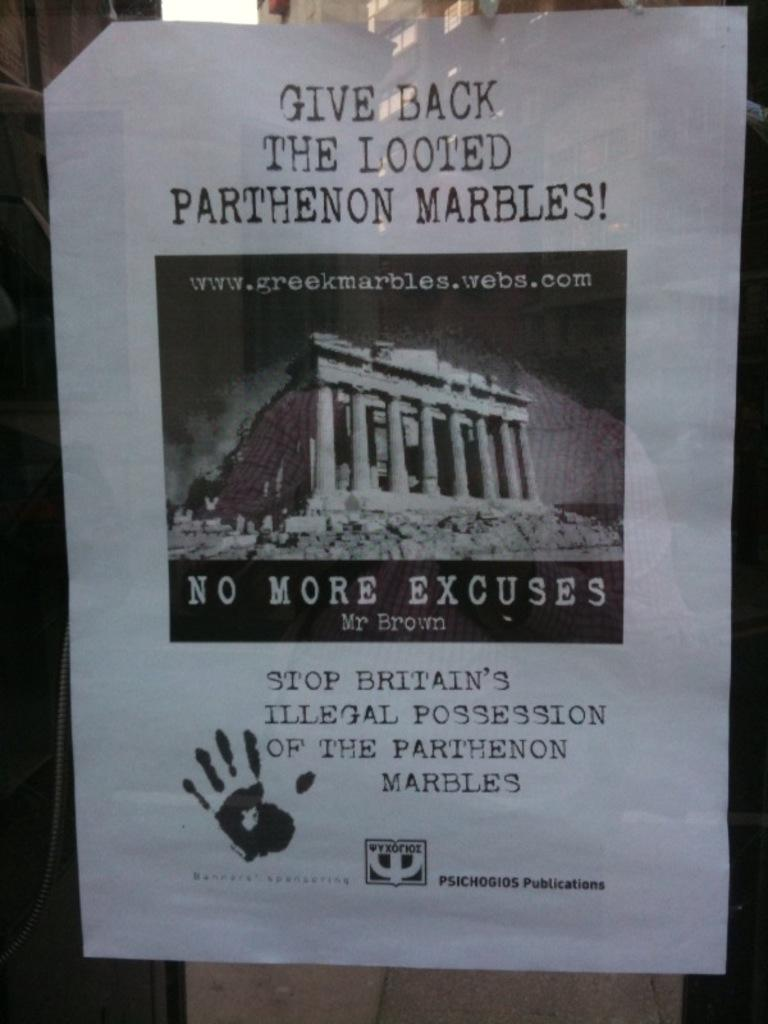What is present on the poster in the image? The poster contains words, a symbol, a logo, and a photo. Can you describe the symbol on the poster? Unfortunately, the specific symbol cannot be described without more information about its appearance. What is the background of the image? There is a wall in the background of the image. What material is visible in the image? There is glass in the image. How many fingers can be seen pointing at the logo on the poster? There are no fingers visible in the image, so it is not possible to determine how many fingers might be pointing at the logo. 